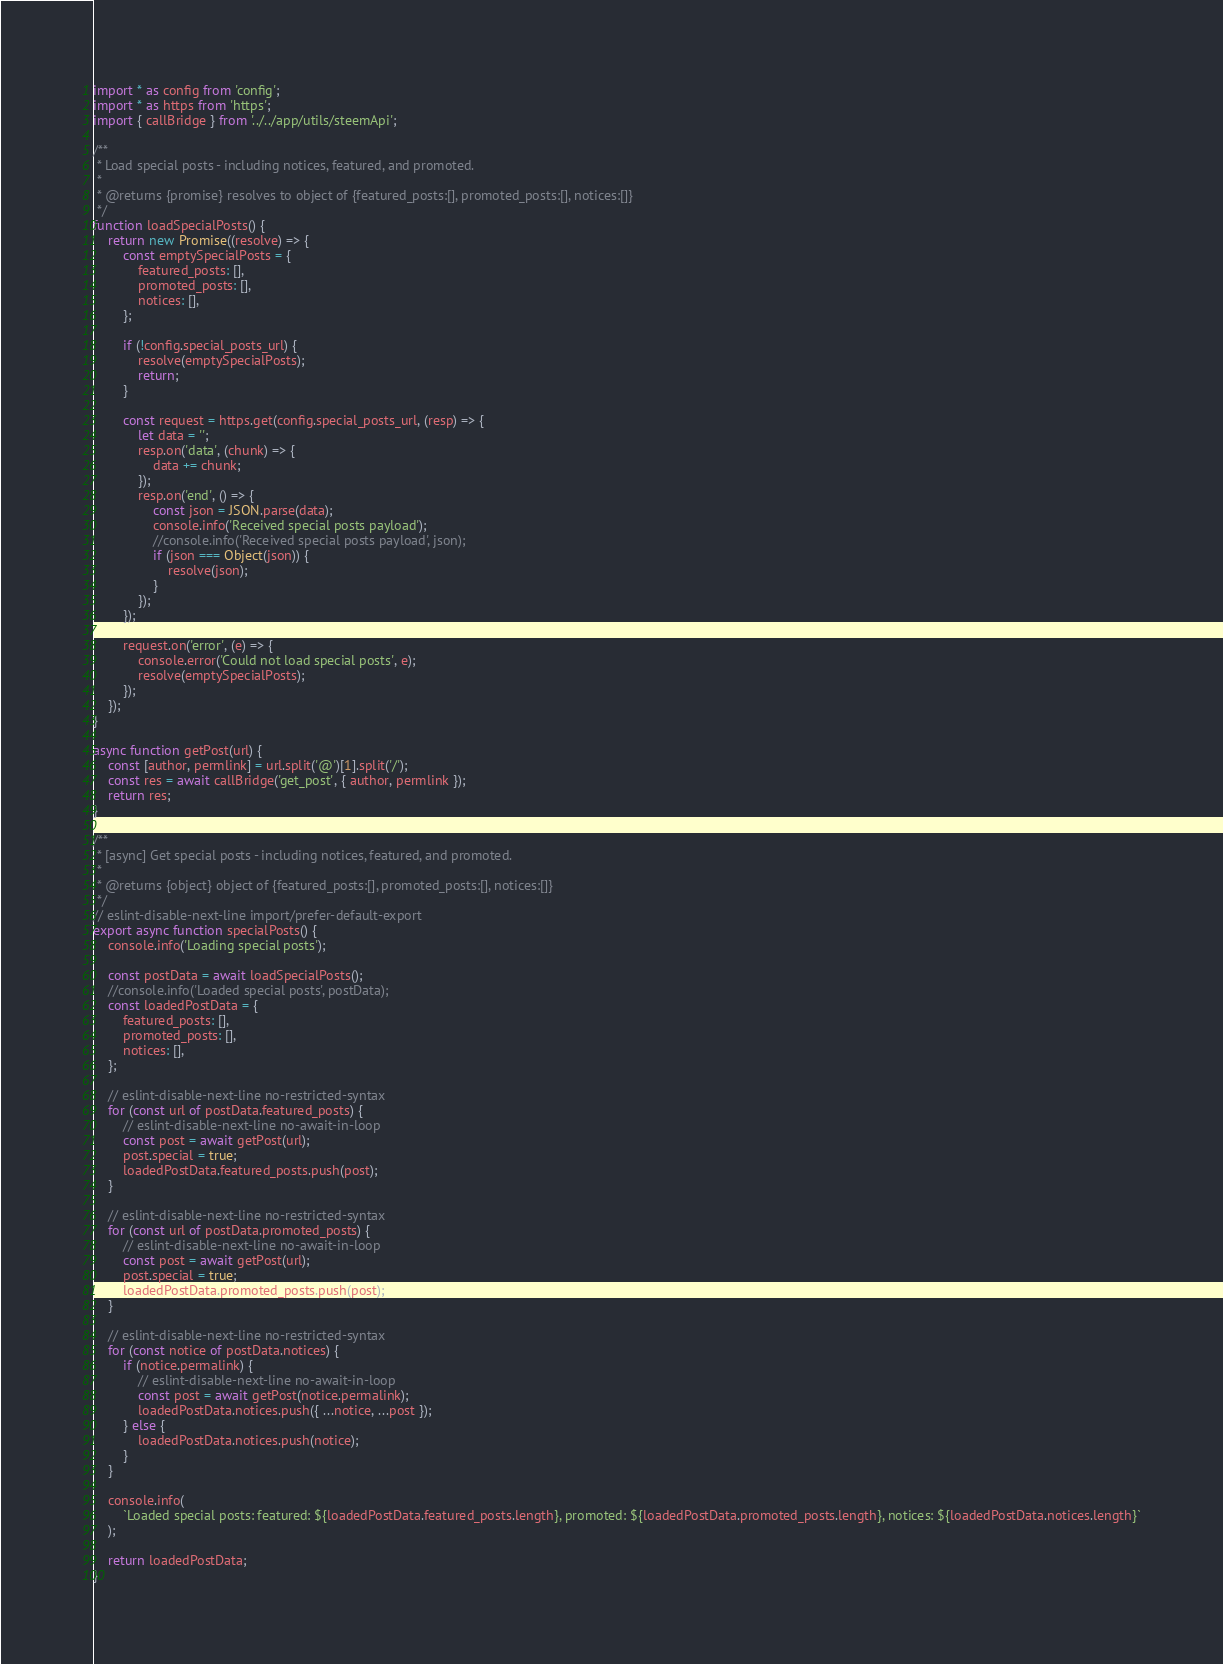<code> <loc_0><loc_0><loc_500><loc_500><_JavaScript_>import * as config from 'config';
import * as https from 'https';
import { callBridge } from '../../app/utils/steemApi';

/**
 * Load special posts - including notices, featured, and promoted.
 *
 * @returns {promise} resolves to object of {featured_posts:[], promoted_posts:[], notices:[]}
 */
function loadSpecialPosts() {
    return new Promise((resolve) => {
        const emptySpecialPosts = {
            featured_posts: [],
            promoted_posts: [],
            notices: [],
        };

        if (!config.special_posts_url) {
            resolve(emptySpecialPosts);
            return;
        }

        const request = https.get(config.special_posts_url, (resp) => {
            let data = '';
            resp.on('data', (chunk) => {
                data += chunk;
            });
            resp.on('end', () => {
                const json = JSON.parse(data);
                console.info('Received special posts payload');
                //console.info('Received special posts payload', json);
                if (json === Object(json)) {
                    resolve(json);
                }
            });
        });

        request.on('error', (e) => {
            console.error('Could not load special posts', e);
            resolve(emptySpecialPosts);
        });
    });
}

async function getPost(url) {
    const [author, permlink] = url.split('@')[1].split('/');
    const res = await callBridge('get_post', { author, permlink });
    return res;
}

/**
 * [async] Get special posts - including notices, featured, and promoted.
 *
 * @returns {object} object of {featured_posts:[], promoted_posts:[], notices:[]}
 */
// eslint-disable-next-line import/prefer-default-export
export async function specialPosts() {
    console.info('Loading special posts');

    const postData = await loadSpecialPosts();
    //console.info('Loaded special posts', postData);
    const loadedPostData = {
        featured_posts: [],
        promoted_posts: [],
        notices: [],
    };

    // eslint-disable-next-line no-restricted-syntax
    for (const url of postData.featured_posts) {
        // eslint-disable-next-line no-await-in-loop
        const post = await getPost(url);
        post.special = true;
        loadedPostData.featured_posts.push(post);
    }

    // eslint-disable-next-line no-restricted-syntax
    for (const url of postData.promoted_posts) {
        // eslint-disable-next-line no-await-in-loop
        const post = await getPost(url);
        post.special = true;
        loadedPostData.promoted_posts.push(post);
    }

    // eslint-disable-next-line no-restricted-syntax
    for (const notice of postData.notices) {
        if (notice.permalink) {
            // eslint-disable-next-line no-await-in-loop
            const post = await getPost(notice.permalink);
            loadedPostData.notices.push({ ...notice, ...post });
        } else {
            loadedPostData.notices.push(notice);
        }
    }

    console.info(
        `Loaded special posts: featured: ${loadedPostData.featured_posts.length}, promoted: ${loadedPostData.promoted_posts.length}, notices: ${loadedPostData.notices.length}`
    );

    return loadedPostData;
}
</code> 